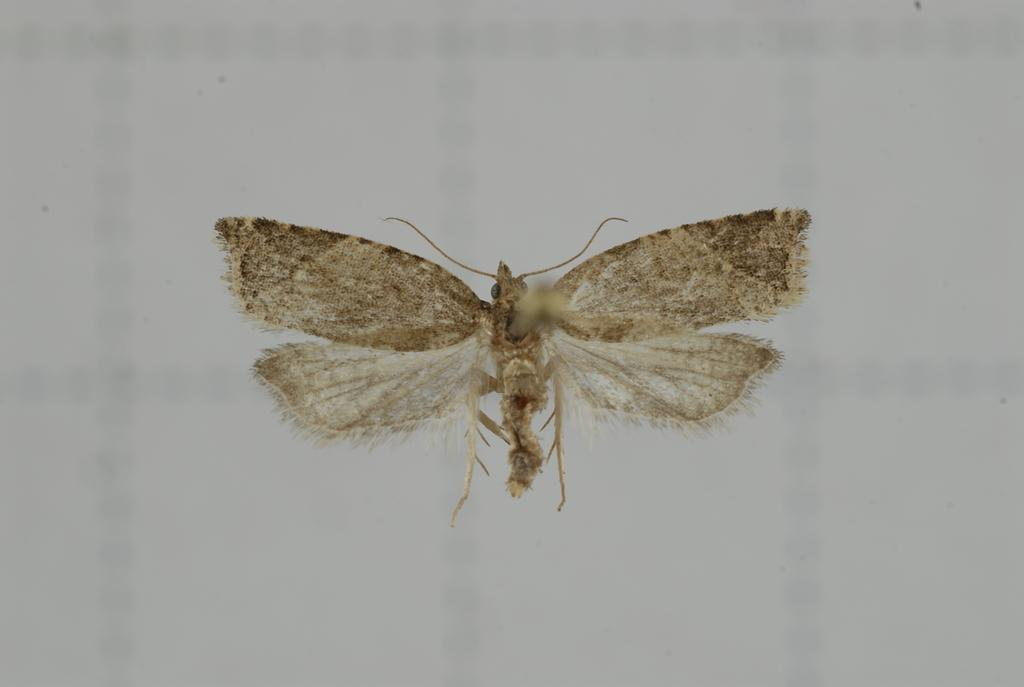What is the main subject of the image? The main subject of the image is an insect. Can you describe the location of the insect in the image? The insect is in the center of the image. What type of jewel is the insect holding in the image? There is no jewel present in the image, and the insect is not holding anything. 